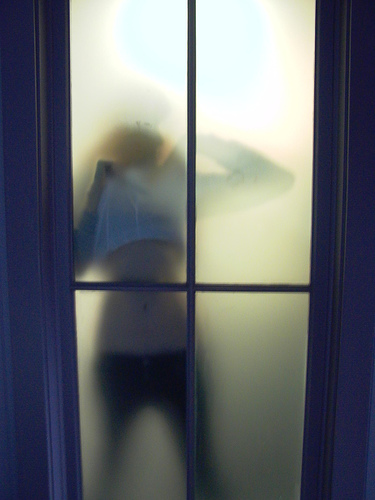<image>
Can you confirm if the person is behind the window? Yes. From this viewpoint, the person is positioned behind the window, with the window partially or fully occluding the person. 